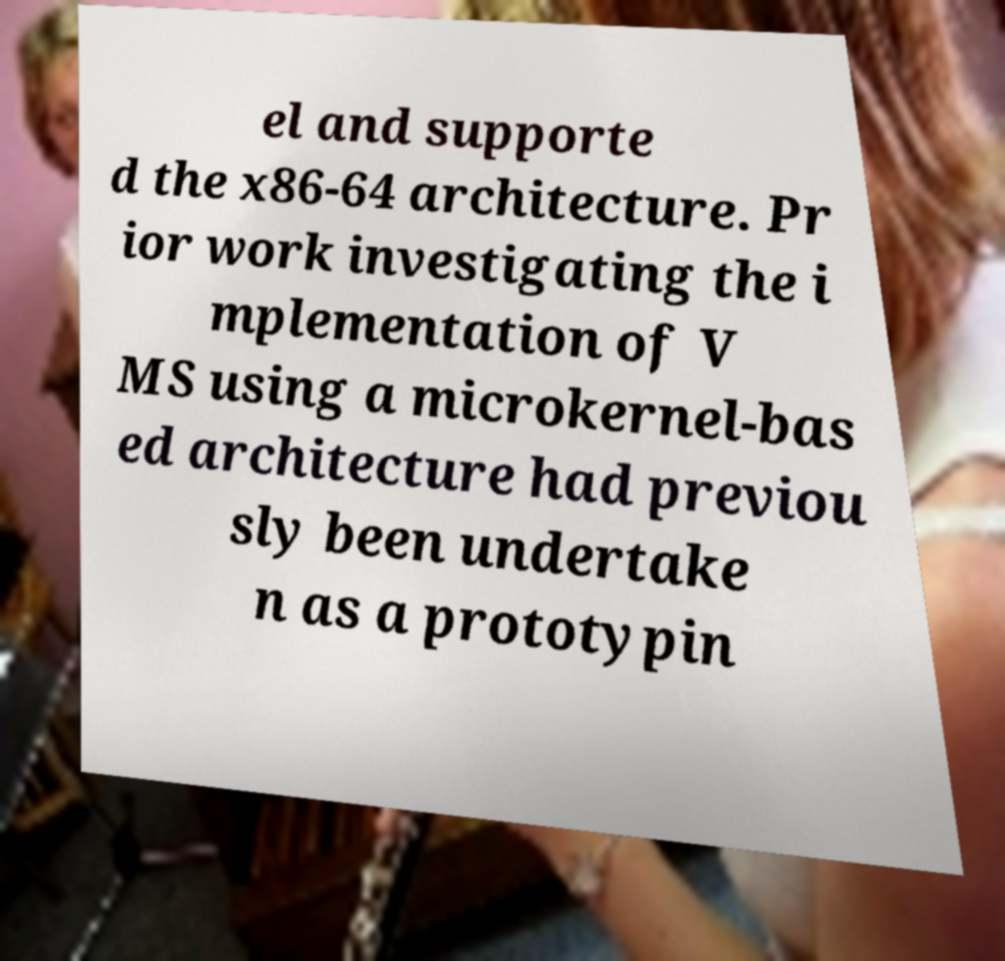I need the written content from this picture converted into text. Can you do that? el and supporte d the x86-64 architecture. Pr ior work investigating the i mplementation of V MS using a microkernel-bas ed architecture had previou sly been undertake n as a prototypin 